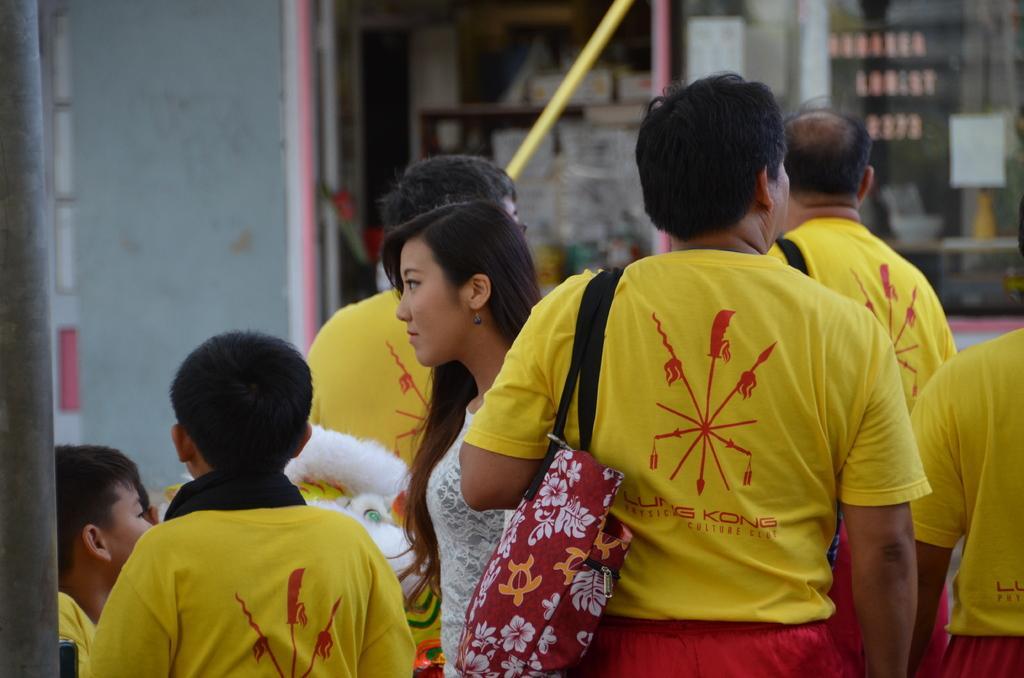Can you describe this image briefly? In this picture there are group of people with yellow color t-shirts and there is a woman with white color dress is stunning. At the back there is a building and there are boards and there is text on the boards and there are objects in the cupboard behind the glass. On the left side of the image there is a pole. 